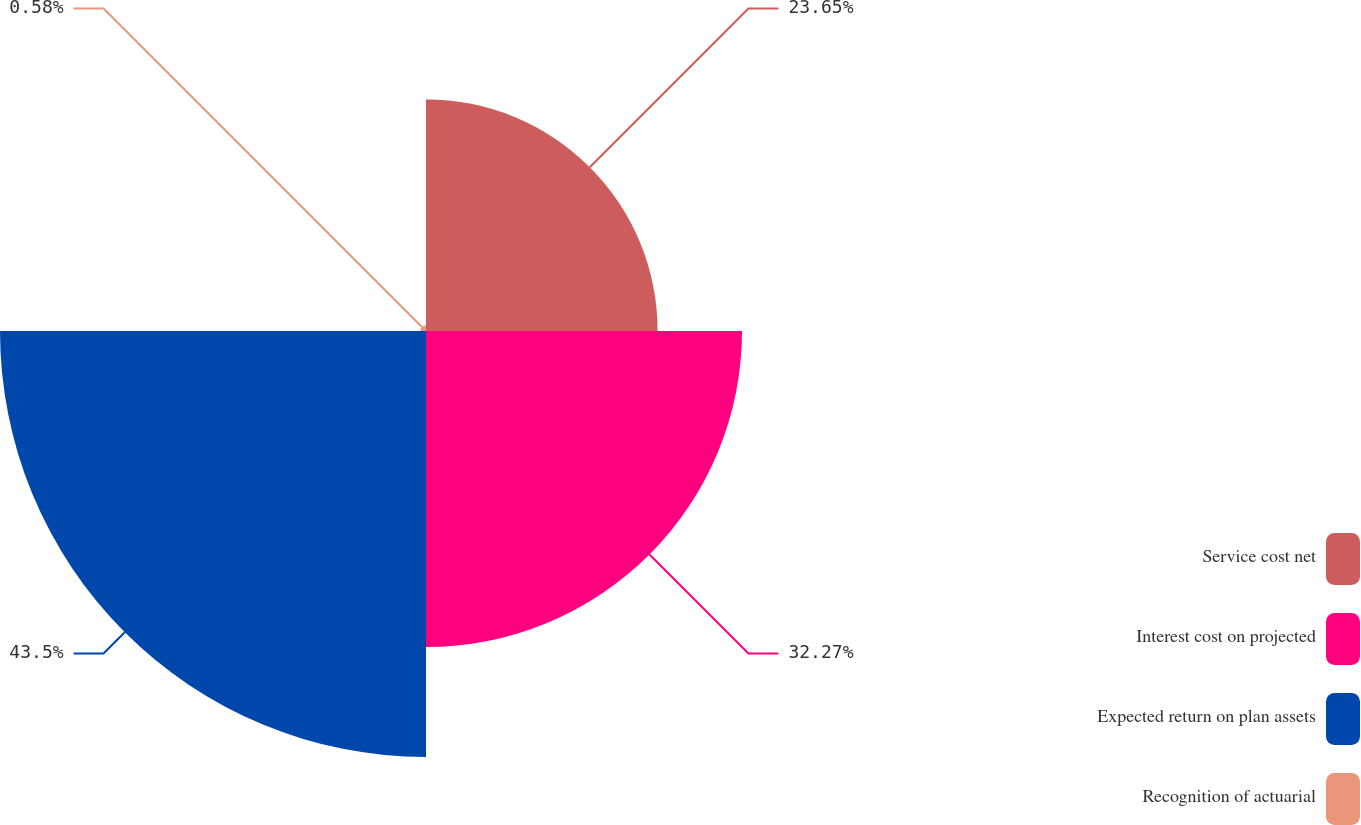Convert chart. <chart><loc_0><loc_0><loc_500><loc_500><pie_chart><fcel>Service cost net<fcel>Interest cost on projected<fcel>Expected return on plan assets<fcel>Recognition of actuarial<nl><fcel>23.65%<fcel>32.27%<fcel>43.5%<fcel>0.58%<nl></chart> 